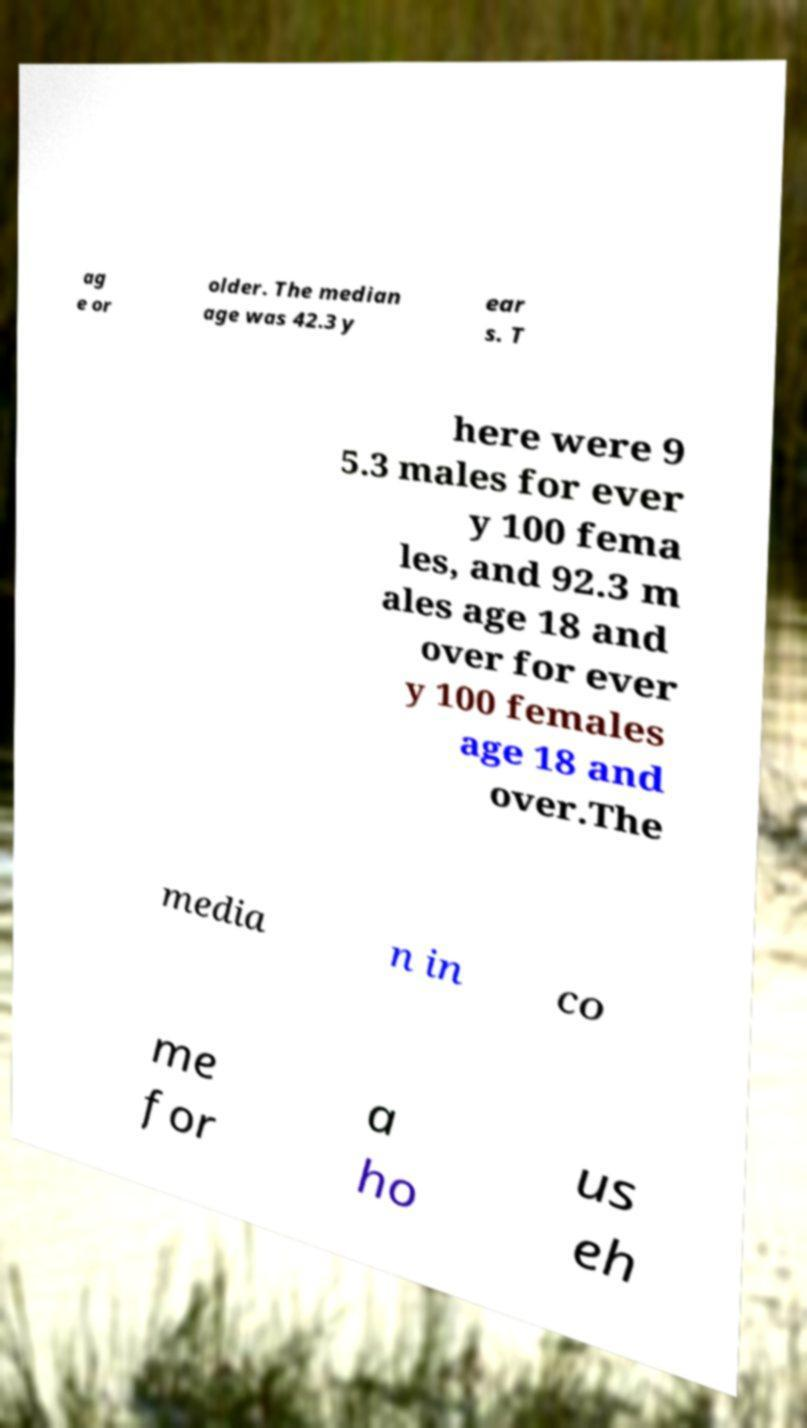There's text embedded in this image that I need extracted. Can you transcribe it verbatim? ag e or older. The median age was 42.3 y ear s. T here were 9 5.3 males for ever y 100 fema les, and 92.3 m ales age 18 and over for ever y 100 females age 18 and over.The media n in co me for a ho us eh 